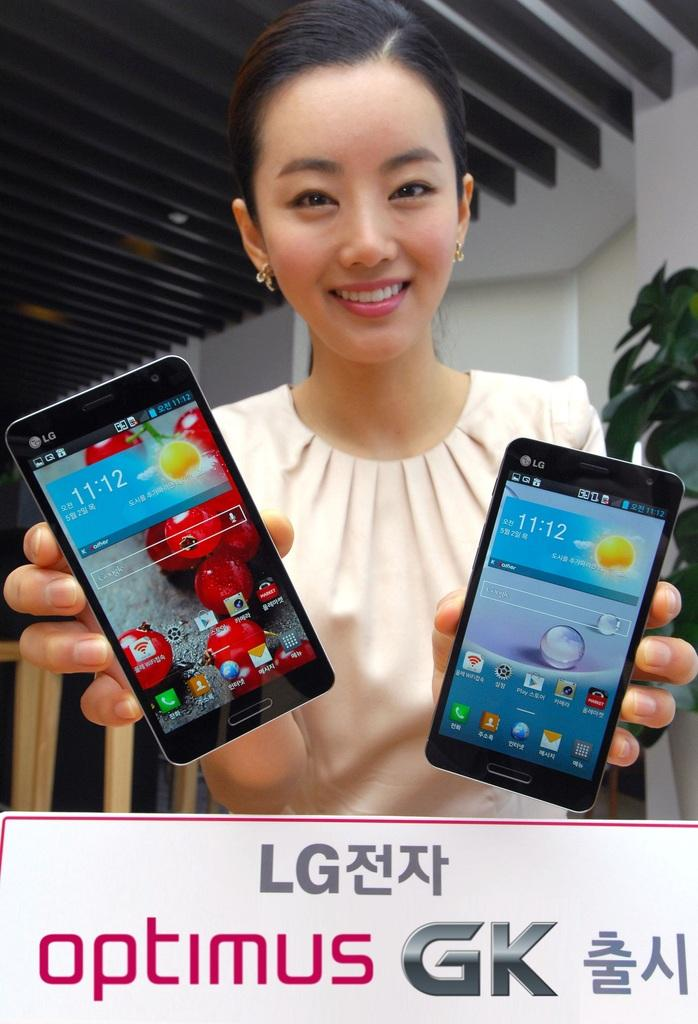<image>
Render a clear and concise summary of the photo. The girl shows two mobile phones made by LG. 